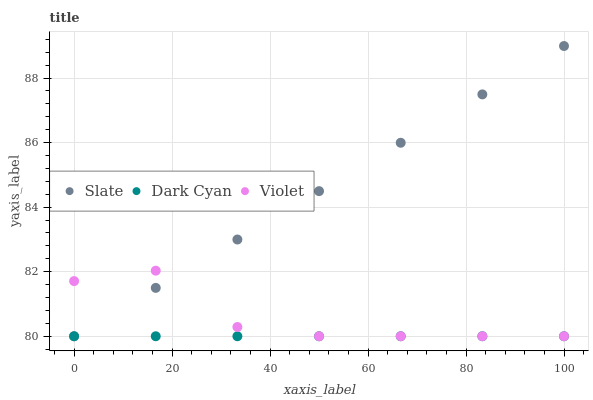Does Dark Cyan have the minimum area under the curve?
Answer yes or no. Yes. Does Slate have the maximum area under the curve?
Answer yes or no. Yes. Does Violet have the minimum area under the curve?
Answer yes or no. No. Does Violet have the maximum area under the curve?
Answer yes or no. No. Is Dark Cyan the smoothest?
Answer yes or no. Yes. Is Violet the roughest?
Answer yes or no. Yes. Is Slate the smoothest?
Answer yes or no. No. Is Slate the roughest?
Answer yes or no. No. Does Dark Cyan have the lowest value?
Answer yes or no. Yes. Does Slate have the highest value?
Answer yes or no. Yes. Does Violet have the highest value?
Answer yes or no. No. Does Slate intersect Dark Cyan?
Answer yes or no. Yes. Is Slate less than Dark Cyan?
Answer yes or no. No. Is Slate greater than Dark Cyan?
Answer yes or no. No. 